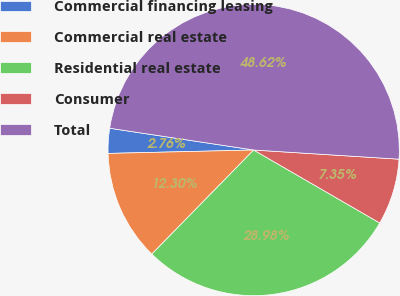Convert chart. <chart><loc_0><loc_0><loc_500><loc_500><pie_chart><fcel>Commercial financing leasing<fcel>Commercial real estate<fcel>Residential real estate<fcel>Consumer<fcel>Total<nl><fcel>2.76%<fcel>12.3%<fcel>28.98%<fcel>7.35%<fcel>48.62%<nl></chart> 